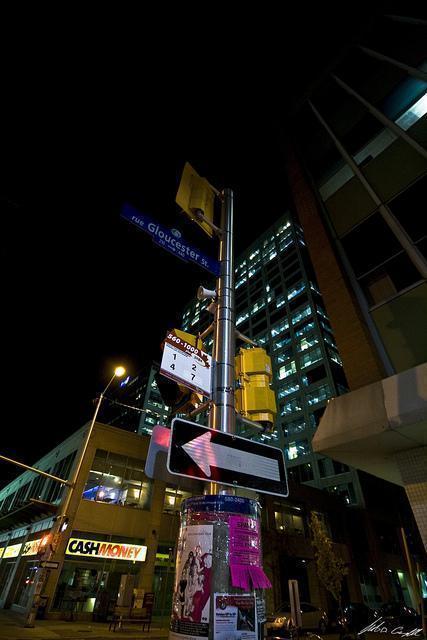What does the white arrow sign usually mean?
Choose the correct response and explain in the format: 'Answer: answer
Rationale: rationale.'
Options: Stop, one way, no turns, yield. Answer: one way.
Rationale: The white arrow means one way. 